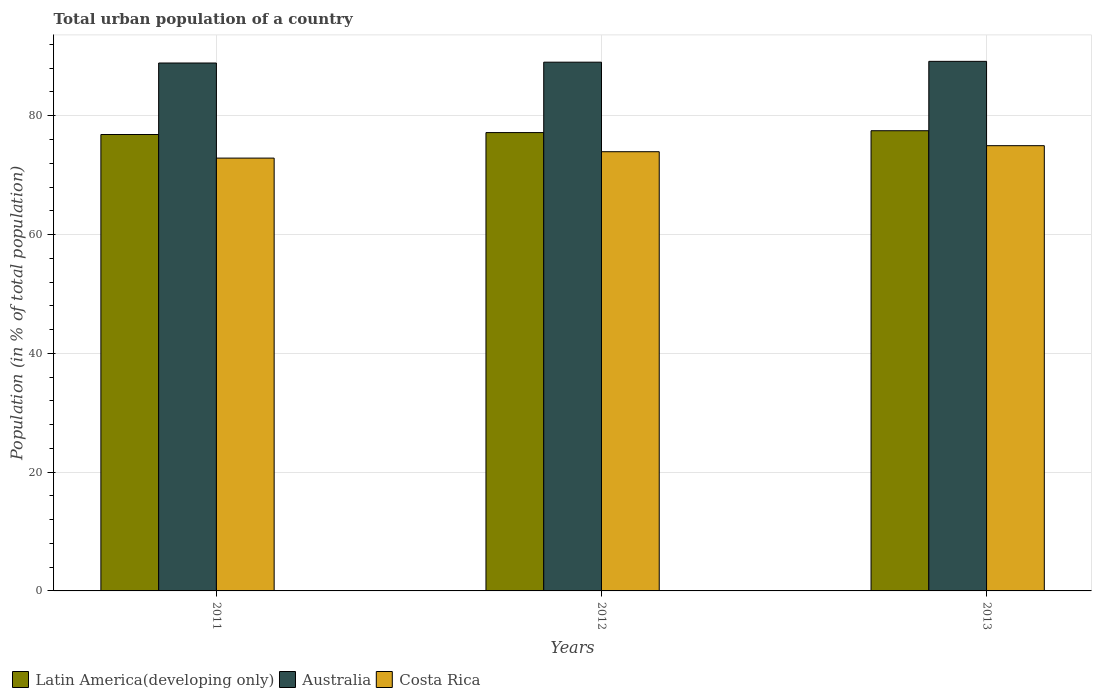How many groups of bars are there?
Keep it short and to the point. 3. How many bars are there on the 1st tick from the left?
Your answer should be compact. 3. How many bars are there on the 1st tick from the right?
Your answer should be compact. 3. What is the label of the 1st group of bars from the left?
Your answer should be very brief. 2011. In how many cases, is the number of bars for a given year not equal to the number of legend labels?
Make the answer very short. 0. What is the urban population in Australia in 2011?
Your answer should be compact. 88.88. Across all years, what is the maximum urban population in Costa Rica?
Your answer should be compact. 74.96. Across all years, what is the minimum urban population in Latin America(developing only)?
Your answer should be very brief. 76.84. In which year was the urban population in Australia maximum?
Keep it short and to the point. 2013. In which year was the urban population in Australia minimum?
Your answer should be compact. 2011. What is the total urban population in Latin America(developing only) in the graph?
Your answer should be very brief. 231.47. What is the difference between the urban population in Costa Rica in 2012 and that in 2013?
Offer a terse response. -1.02. What is the difference between the urban population in Costa Rica in 2011 and the urban population in Latin America(developing only) in 2012?
Your answer should be compact. -4.29. What is the average urban population in Australia per year?
Provide a succinct answer. 89.01. In the year 2013, what is the difference between the urban population in Australia and urban population in Costa Rica?
Provide a succinct answer. 14.2. In how many years, is the urban population in Latin America(developing only) greater than 16 %?
Keep it short and to the point. 3. What is the ratio of the urban population in Costa Rica in 2011 to that in 2012?
Provide a succinct answer. 0.99. What is the difference between the highest and the second highest urban population in Australia?
Make the answer very short. 0.14. What is the difference between the highest and the lowest urban population in Australia?
Your response must be concise. 0.28. Is the sum of the urban population in Australia in 2011 and 2012 greater than the maximum urban population in Costa Rica across all years?
Offer a terse response. Yes. What does the 1st bar from the left in 2011 represents?
Make the answer very short. Latin America(developing only). What does the 2nd bar from the right in 2011 represents?
Offer a terse response. Australia. How many bars are there?
Provide a short and direct response. 9. Are all the bars in the graph horizontal?
Ensure brevity in your answer.  No. How many years are there in the graph?
Give a very brief answer. 3. What is the difference between two consecutive major ticks on the Y-axis?
Give a very brief answer. 20. Are the values on the major ticks of Y-axis written in scientific E-notation?
Your answer should be compact. No. Does the graph contain grids?
Offer a terse response. Yes. What is the title of the graph?
Offer a very short reply. Total urban population of a country. Does "Hong Kong" appear as one of the legend labels in the graph?
Offer a very short reply. No. What is the label or title of the X-axis?
Your answer should be very brief. Years. What is the label or title of the Y-axis?
Make the answer very short. Population (in % of total population). What is the Population (in % of total population) of Latin America(developing only) in 2011?
Your answer should be compact. 76.84. What is the Population (in % of total population) in Australia in 2011?
Provide a succinct answer. 88.88. What is the Population (in % of total population) of Costa Rica in 2011?
Ensure brevity in your answer.  72.87. What is the Population (in % of total population) of Latin America(developing only) in 2012?
Give a very brief answer. 77.16. What is the Population (in % of total population) in Australia in 2012?
Ensure brevity in your answer.  89.02. What is the Population (in % of total population) of Costa Rica in 2012?
Offer a terse response. 73.94. What is the Population (in % of total population) in Latin America(developing only) in 2013?
Ensure brevity in your answer.  77.47. What is the Population (in % of total population) of Australia in 2013?
Make the answer very short. 89.15. What is the Population (in % of total population) in Costa Rica in 2013?
Offer a very short reply. 74.96. Across all years, what is the maximum Population (in % of total population) of Latin America(developing only)?
Your response must be concise. 77.47. Across all years, what is the maximum Population (in % of total population) in Australia?
Offer a very short reply. 89.15. Across all years, what is the maximum Population (in % of total population) of Costa Rica?
Ensure brevity in your answer.  74.96. Across all years, what is the minimum Population (in % of total population) of Latin America(developing only)?
Make the answer very short. 76.84. Across all years, what is the minimum Population (in % of total population) in Australia?
Offer a terse response. 88.88. Across all years, what is the minimum Population (in % of total population) of Costa Rica?
Provide a short and direct response. 72.87. What is the total Population (in % of total population) in Latin America(developing only) in the graph?
Provide a short and direct response. 231.47. What is the total Population (in % of total population) in Australia in the graph?
Your answer should be very brief. 267.04. What is the total Population (in % of total population) of Costa Rica in the graph?
Offer a very short reply. 221.76. What is the difference between the Population (in % of total population) in Latin America(developing only) in 2011 and that in 2012?
Your response must be concise. -0.32. What is the difference between the Population (in % of total population) of Australia in 2011 and that in 2012?
Keep it short and to the point. -0.14. What is the difference between the Population (in % of total population) of Costa Rica in 2011 and that in 2012?
Ensure brevity in your answer.  -1.07. What is the difference between the Population (in % of total population) of Latin America(developing only) in 2011 and that in 2013?
Provide a short and direct response. -0.64. What is the difference between the Population (in % of total population) in Australia in 2011 and that in 2013?
Offer a terse response. -0.28. What is the difference between the Population (in % of total population) of Costa Rica in 2011 and that in 2013?
Provide a succinct answer. -2.09. What is the difference between the Population (in % of total population) of Latin America(developing only) in 2012 and that in 2013?
Provide a succinct answer. -0.31. What is the difference between the Population (in % of total population) of Australia in 2012 and that in 2013?
Keep it short and to the point. -0.14. What is the difference between the Population (in % of total population) of Costa Rica in 2012 and that in 2013?
Your answer should be very brief. -1.02. What is the difference between the Population (in % of total population) of Latin America(developing only) in 2011 and the Population (in % of total population) of Australia in 2012?
Your answer should be very brief. -12.18. What is the difference between the Population (in % of total population) in Latin America(developing only) in 2011 and the Population (in % of total population) in Costa Rica in 2012?
Offer a very short reply. 2.9. What is the difference between the Population (in % of total population) of Australia in 2011 and the Population (in % of total population) of Costa Rica in 2012?
Make the answer very short. 14.94. What is the difference between the Population (in % of total population) in Latin America(developing only) in 2011 and the Population (in % of total population) in Australia in 2013?
Give a very brief answer. -12.31. What is the difference between the Population (in % of total population) in Latin America(developing only) in 2011 and the Population (in % of total population) in Costa Rica in 2013?
Your response must be concise. 1.88. What is the difference between the Population (in % of total population) in Australia in 2011 and the Population (in % of total population) in Costa Rica in 2013?
Your answer should be compact. 13.92. What is the difference between the Population (in % of total population) of Latin America(developing only) in 2012 and the Population (in % of total population) of Australia in 2013?
Provide a short and direct response. -11.99. What is the difference between the Population (in % of total population) in Latin America(developing only) in 2012 and the Population (in % of total population) in Costa Rica in 2013?
Offer a very short reply. 2.2. What is the difference between the Population (in % of total population) of Australia in 2012 and the Population (in % of total population) of Costa Rica in 2013?
Give a very brief answer. 14.06. What is the average Population (in % of total population) in Latin America(developing only) per year?
Keep it short and to the point. 77.16. What is the average Population (in % of total population) of Australia per year?
Your answer should be compact. 89.01. What is the average Population (in % of total population) in Costa Rica per year?
Provide a short and direct response. 73.92. In the year 2011, what is the difference between the Population (in % of total population) of Latin America(developing only) and Population (in % of total population) of Australia?
Offer a terse response. -12.04. In the year 2011, what is the difference between the Population (in % of total population) of Latin America(developing only) and Population (in % of total population) of Costa Rica?
Give a very brief answer. 3.97. In the year 2011, what is the difference between the Population (in % of total population) in Australia and Population (in % of total population) in Costa Rica?
Keep it short and to the point. 16.01. In the year 2012, what is the difference between the Population (in % of total population) of Latin America(developing only) and Population (in % of total population) of Australia?
Your answer should be compact. -11.85. In the year 2012, what is the difference between the Population (in % of total population) of Latin America(developing only) and Population (in % of total population) of Costa Rica?
Ensure brevity in your answer.  3.22. In the year 2012, what is the difference between the Population (in % of total population) in Australia and Population (in % of total population) in Costa Rica?
Your answer should be very brief. 15.07. In the year 2013, what is the difference between the Population (in % of total population) of Latin America(developing only) and Population (in % of total population) of Australia?
Give a very brief answer. -11.68. In the year 2013, what is the difference between the Population (in % of total population) of Latin America(developing only) and Population (in % of total population) of Costa Rica?
Provide a short and direct response. 2.52. In the year 2013, what is the difference between the Population (in % of total population) in Australia and Population (in % of total population) in Costa Rica?
Your response must be concise. 14.2. What is the ratio of the Population (in % of total population) of Australia in 2011 to that in 2012?
Your answer should be compact. 1. What is the ratio of the Population (in % of total population) of Costa Rica in 2011 to that in 2012?
Ensure brevity in your answer.  0.99. What is the ratio of the Population (in % of total population) of Latin America(developing only) in 2011 to that in 2013?
Make the answer very short. 0.99. What is the ratio of the Population (in % of total population) in Australia in 2011 to that in 2013?
Give a very brief answer. 1. What is the ratio of the Population (in % of total population) in Costa Rica in 2011 to that in 2013?
Give a very brief answer. 0.97. What is the ratio of the Population (in % of total population) of Latin America(developing only) in 2012 to that in 2013?
Provide a succinct answer. 1. What is the ratio of the Population (in % of total population) in Australia in 2012 to that in 2013?
Your answer should be compact. 1. What is the ratio of the Population (in % of total population) of Costa Rica in 2012 to that in 2013?
Keep it short and to the point. 0.99. What is the difference between the highest and the second highest Population (in % of total population) of Latin America(developing only)?
Keep it short and to the point. 0.31. What is the difference between the highest and the second highest Population (in % of total population) in Australia?
Provide a succinct answer. 0.14. What is the difference between the highest and the second highest Population (in % of total population) of Costa Rica?
Ensure brevity in your answer.  1.02. What is the difference between the highest and the lowest Population (in % of total population) of Latin America(developing only)?
Make the answer very short. 0.64. What is the difference between the highest and the lowest Population (in % of total population) in Australia?
Provide a short and direct response. 0.28. What is the difference between the highest and the lowest Population (in % of total population) of Costa Rica?
Ensure brevity in your answer.  2.09. 